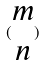Convert formula to latex. <formula><loc_0><loc_0><loc_500><loc_500>( \begin{matrix} m \\ n \end{matrix} )</formula> 